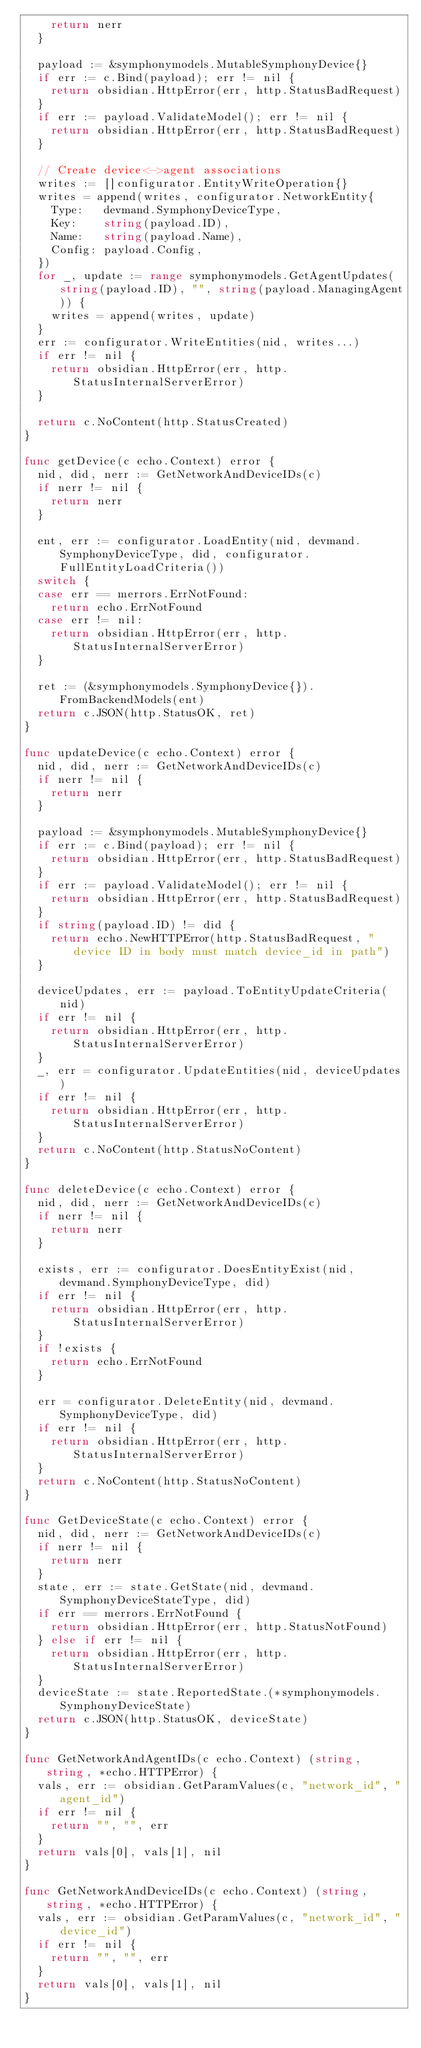Convert code to text. <code><loc_0><loc_0><loc_500><loc_500><_Go_>		return nerr
	}

	payload := &symphonymodels.MutableSymphonyDevice{}
	if err := c.Bind(payload); err != nil {
		return obsidian.HttpError(err, http.StatusBadRequest)
	}
	if err := payload.ValidateModel(); err != nil {
		return obsidian.HttpError(err, http.StatusBadRequest)
	}

	// Create device<->agent associations
	writes := []configurator.EntityWriteOperation{}
	writes = append(writes, configurator.NetworkEntity{
		Type:   devmand.SymphonyDeviceType,
		Key:    string(payload.ID),
		Name:   string(payload.Name),
		Config: payload.Config,
	})
	for _, update := range symphonymodels.GetAgentUpdates(string(payload.ID), "", string(payload.ManagingAgent)) {
		writes = append(writes, update)
	}
	err := configurator.WriteEntities(nid, writes...)
	if err != nil {
		return obsidian.HttpError(err, http.StatusInternalServerError)
	}

	return c.NoContent(http.StatusCreated)
}

func getDevice(c echo.Context) error {
	nid, did, nerr := GetNetworkAndDeviceIDs(c)
	if nerr != nil {
		return nerr
	}

	ent, err := configurator.LoadEntity(nid, devmand.SymphonyDeviceType, did, configurator.FullEntityLoadCriteria())
	switch {
	case err == merrors.ErrNotFound:
		return echo.ErrNotFound
	case err != nil:
		return obsidian.HttpError(err, http.StatusInternalServerError)
	}

	ret := (&symphonymodels.SymphonyDevice{}).FromBackendModels(ent)
	return c.JSON(http.StatusOK, ret)
}

func updateDevice(c echo.Context) error {
	nid, did, nerr := GetNetworkAndDeviceIDs(c)
	if nerr != nil {
		return nerr
	}

	payload := &symphonymodels.MutableSymphonyDevice{}
	if err := c.Bind(payload); err != nil {
		return obsidian.HttpError(err, http.StatusBadRequest)
	}
	if err := payload.ValidateModel(); err != nil {
		return obsidian.HttpError(err, http.StatusBadRequest)
	}
	if string(payload.ID) != did {
		return echo.NewHTTPError(http.StatusBadRequest, "device ID in body must match device_id in path")
	}

	deviceUpdates, err := payload.ToEntityUpdateCriteria(nid)
	if err != nil {
		return obsidian.HttpError(err, http.StatusInternalServerError)
	}
	_, err = configurator.UpdateEntities(nid, deviceUpdates)
	if err != nil {
		return obsidian.HttpError(err, http.StatusInternalServerError)
	}
	return c.NoContent(http.StatusNoContent)
}

func deleteDevice(c echo.Context) error {
	nid, did, nerr := GetNetworkAndDeviceIDs(c)
	if nerr != nil {
		return nerr
	}

	exists, err := configurator.DoesEntityExist(nid, devmand.SymphonyDeviceType, did)
	if err != nil {
		return obsidian.HttpError(err, http.StatusInternalServerError)
	}
	if !exists {
		return echo.ErrNotFound
	}

	err = configurator.DeleteEntity(nid, devmand.SymphonyDeviceType, did)
	if err != nil {
		return obsidian.HttpError(err, http.StatusInternalServerError)
	}
	return c.NoContent(http.StatusNoContent)
}

func GetDeviceState(c echo.Context) error {
	nid, did, nerr := GetNetworkAndDeviceIDs(c)
	if nerr != nil {
		return nerr
	}
	state, err := state.GetState(nid, devmand.SymphonyDeviceStateType, did)
	if err == merrors.ErrNotFound {
		return obsidian.HttpError(err, http.StatusNotFound)
	} else if err != nil {
		return obsidian.HttpError(err, http.StatusInternalServerError)
	}
	deviceState := state.ReportedState.(*symphonymodels.SymphonyDeviceState)
	return c.JSON(http.StatusOK, deviceState)
}

func GetNetworkAndAgentIDs(c echo.Context) (string, string, *echo.HTTPError) {
	vals, err := obsidian.GetParamValues(c, "network_id", "agent_id")
	if err != nil {
		return "", "", err
	}
	return vals[0], vals[1], nil
}

func GetNetworkAndDeviceIDs(c echo.Context) (string, string, *echo.HTTPError) {
	vals, err := obsidian.GetParamValues(c, "network_id", "device_id")
	if err != nil {
		return "", "", err
	}
	return vals[0], vals[1], nil
}
</code> 